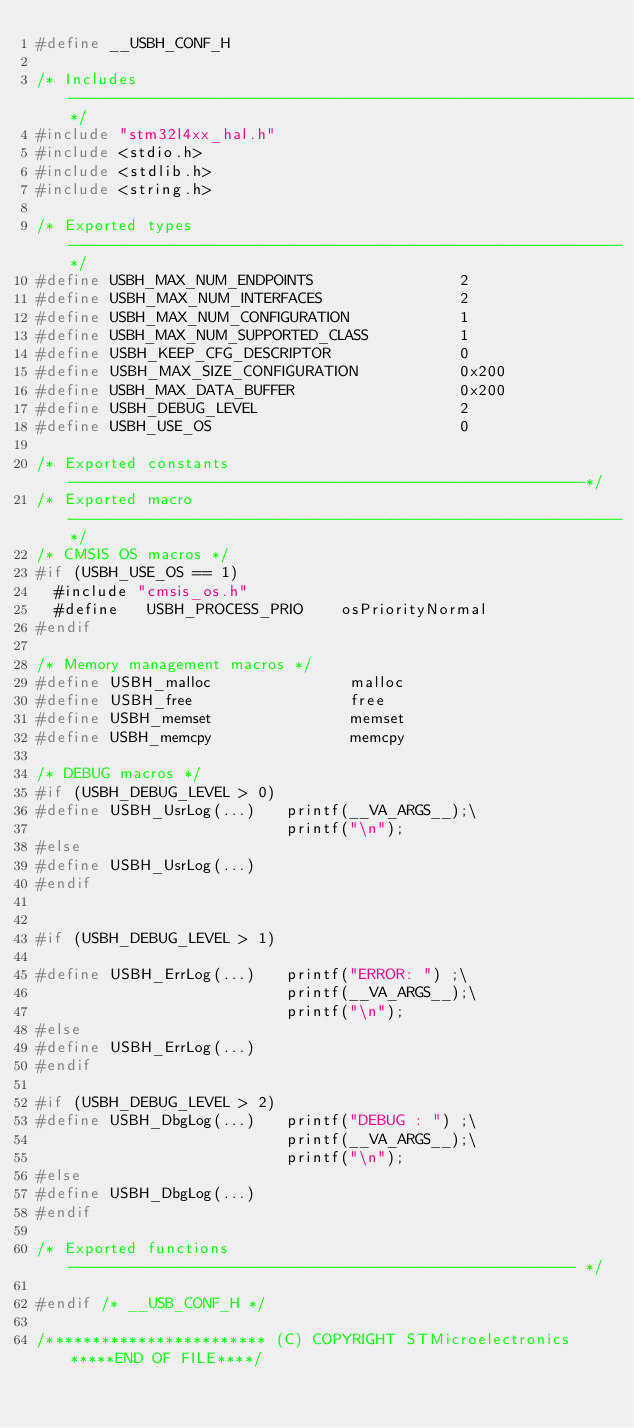<code> <loc_0><loc_0><loc_500><loc_500><_C_>#define __USBH_CONF_H

/* Includes ------------------------------------------------------------------*/
#include "stm32l4xx_hal.h"
#include <stdio.h>
#include <stdlib.h>
#include <string.h>

/* Exported types ------------------------------------------------------------*/
#define USBH_MAX_NUM_ENDPOINTS                2
#define USBH_MAX_NUM_INTERFACES               2
#define USBH_MAX_NUM_CONFIGURATION            1
#define USBH_MAX_NUM_SUPPORTED_CLASS          1
#define USBH_KEEP_CFG_DESCRIPTOR              0
#define USBH_MAX_SIZE_CONFIGURATION           0x200
#define USBH_MAX_DATA_BUFFER                  0x200
#define USBH_DEBUG_LEVEL                      2
#define USBH_USE_OS                           0

/* Exported constants --------------------------------------------------------*/
/* Exported macro ------------------------------------------------------------*/
/* CMSIS OS macros */   
#if (USBH_USE_OS == 1)
  #include "cmsis_os.h"
  #define   USBH_PROCESS_PRIO    osPriorityNormal
#endif

/* Memory management macros */   
#define USBH_malloc               malloc
#define USBH_free                 free
#define USBH_memset               memset
#define USBH_memcpy               memcpy
    
/* DEBUG macros */   
#if (USBH_DEBUG_LEVEL > 0)
#define USBH_UsrLog(...)   printf(__VA_ARGS__);\
                           printf("\n");
#else
#define USBH_UsrLog(...)   
#endif 
                            
                            
#if (USBH_DEBUG_LEVEL > 1)

#define USBH_ErrLog(...)   printf("ERROR: ") ;\
                           printf(__VA_ARGS__);\
                           printf("\n");
#else
#define USBH_ErrLog(...)   
#endif 
                                                      
#if (USBH_DEBUG_LEVEL > 2)                         
#define USBH_DbgLog(...)   printf("DEBUG : ") ;\
                           printf(__VA_ARGS__);\
                           printf("\n");
#else
#define USBH_DbgLog(...)                         
#endif

/* Exported functions ------------------------------------------------------- */

#endif /* __USB_CONF_H */

/************************ (C) COPYRIGHT STMicroelectronics *****END OF FILE****/
</code> 